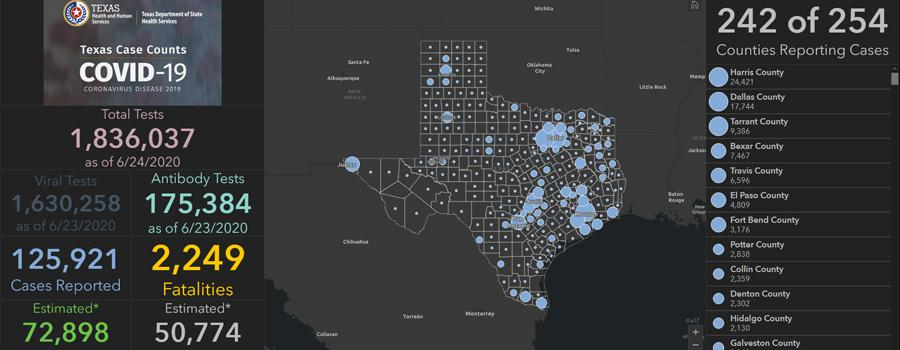Point out several critical features in this image. The estimated number of cases reported and the estimated number of fatalities differ by 22,124. The case differs in Harris and Dallas counties with a reported 6,677.. In Travis and Potter counties combined, a total of 9,434 cases have been reported. The reported case and fatalities differ by 123,672... 